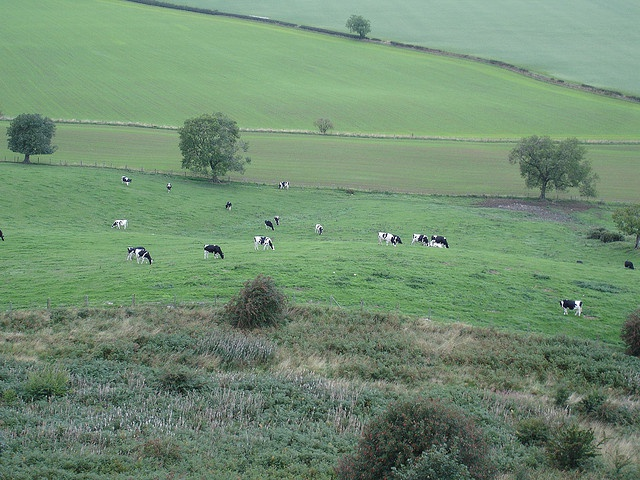Describe the objects in this image and their specific colors. I can see cow in lightgreen, green, darkgray, and gray tones, cow in lightgreen, black, white, teal, and darkgray tones, cow in lightgreen, black, darkgray, green, and navy tones, cow in lightgreen, white, darkgray, black, and gray tones, and cow in lightgreen, black, darkgray, white, and gray tones in this image. 